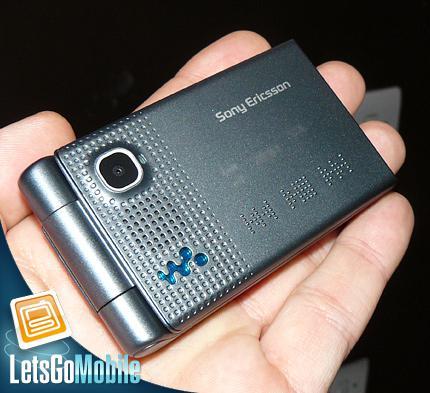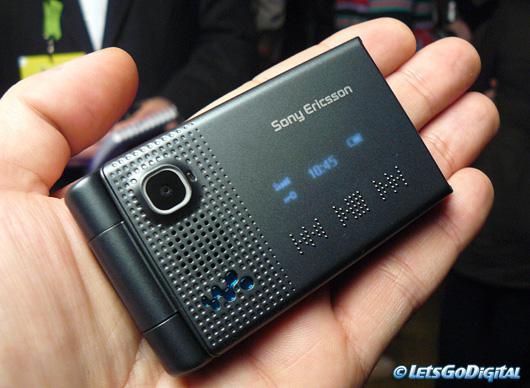The first image is the image on the left, the second image is the image on the right. For the images shown, is this caption "The image on the left shows an opened flip phone." true? Answer yes or no. No. The first image is the image on the left, the second image is the image on the right. For the images shown, is this caption "Three phones are laid out neatly side by side in one of the pictures." true? Answer yes or no. No. 